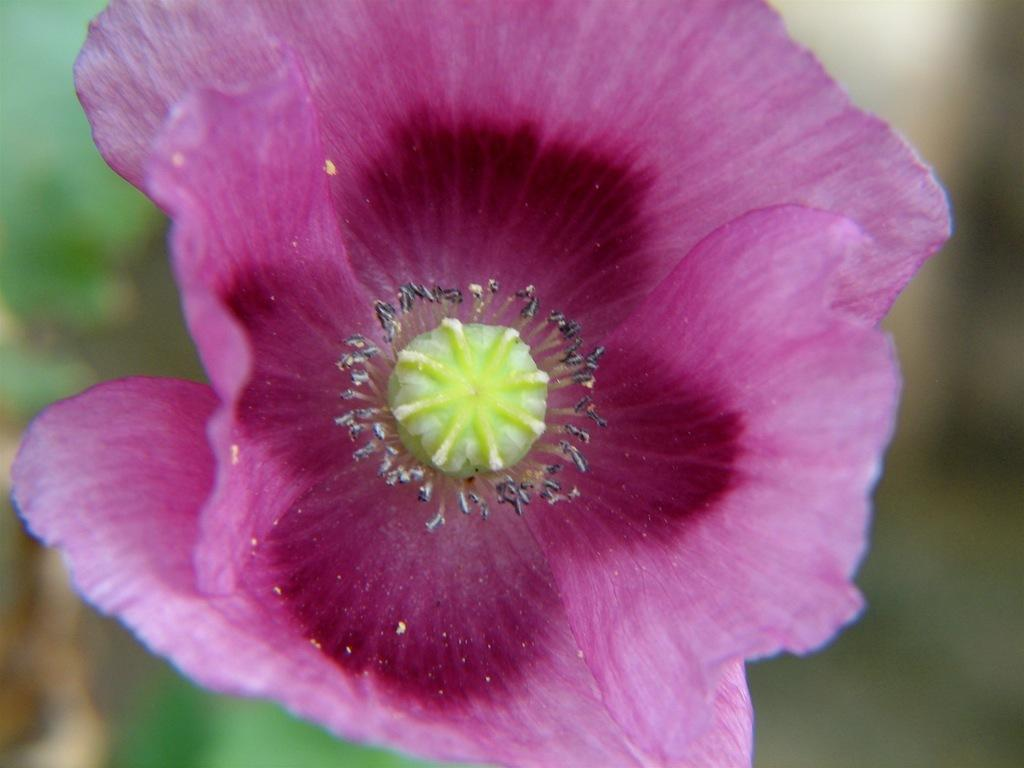What type of flower can be seen in the image? There is a purple flower in the image. What color are the objects in the image? The objects in the image are black. How would you describe the quality of the image's background? The image is blurry in the background. What type of alley can be seen in the image? There is no alley present in the image. How many zippers are visible on the purple flower? There are no zippers on the purple flower, as it is a natural object and not a man-made item with zippers. 